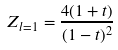Convert formula to latex. <formula><loc_0><loc_0><loc_500><loc_500>Z _ { l = 1 } = \frac { 4 ( 1 + t ) } { ( 1 - t ) ^ { 2 } }</formula> 